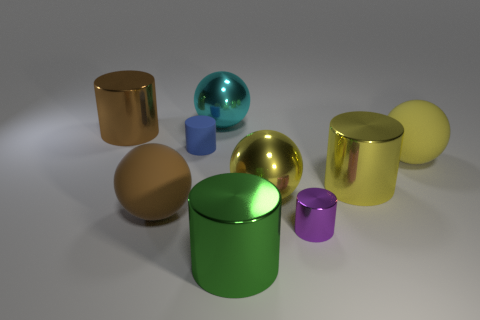What materials do the objects in the image appear to be made from? The objects in the image seem to have surfaces that resemble various materials. The shinier ones could be metallic, while the matte finished ones with less reflection look like they could be made of rubber. 